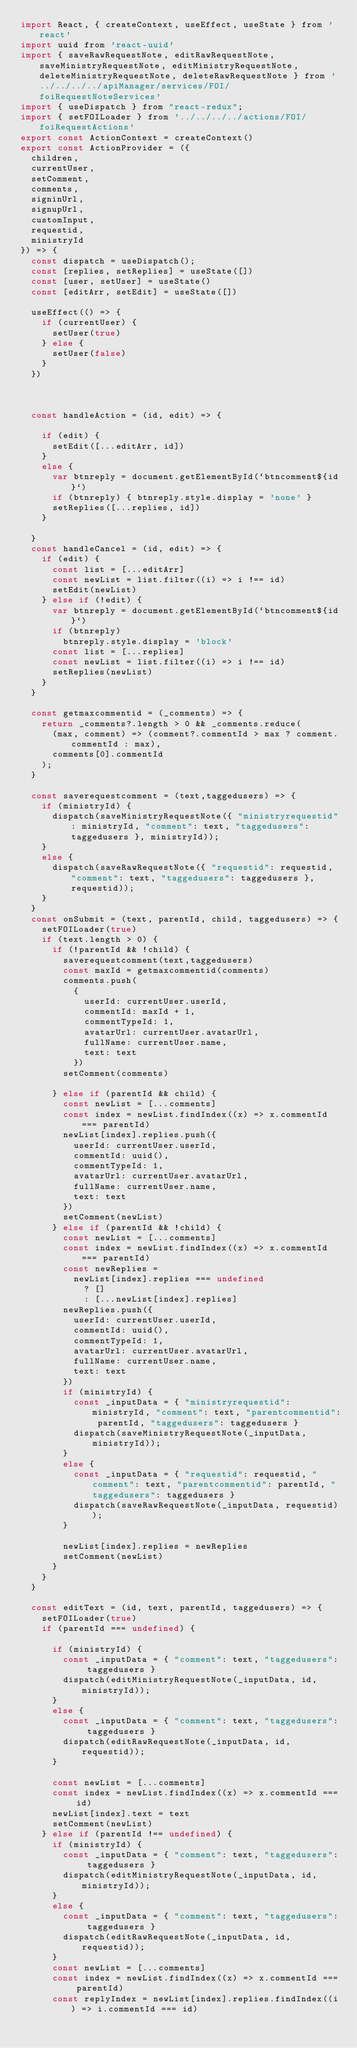<code> <loc_0><loc_0><loc_500><loc_500><_JavaScript_>import React, { createContext, useEffect, useState } from 'react'
import uuid from 'react-uuid'
import { saveRawRequestNote, editRawRequestNote, saveMinistryRequestNote, editMinistryRequestNote, deleteMinistryRequestNote, deleteRawRequestNote } from '../../../../apiManager/services/FOI/foiRequestNoteServices'
import { useDispatch } from "react-redux";
import { setFOILoader } from '../../../../actions/FOI/foiRequestActions'
export const ActionContext = createContext()
export const ActionProvider = ({
  children,
  currentUser,
  setComment,
  comments,
  signinUrl,
  signupUrl,
  customInput,
  requestid,
  ministryId
}) => {
  const dispatch = useDispatch();
  const [replies, setReplies] = useState([])
  const [user, setUser] = useState()
  const [editArr, setEdit] = useState([])

  useEffect(() => {
    if (currentUser) {
      setUser(true)
    } else {
      setUser(false)
    }
  })



  const handleAction = (id, edit) => {

    if (edit) {
      setEdit([...editArr, id])
    }
    else {
      var btnreply = document.getElementById(`btncomment${id}`)
      if (btnreply) { btnreply.style.display = 'none' }
      setReplies([...replies, id])
    }

  }
  const handleCancel = (id, edit) => {
    if (edit) {
      const list = [...editArr]
      const newList = list.filter((i) => i !== id)
      setEdit(newList)
    } else if (!edit) {
      var btnreply = document.getElementById(`btncomment${id}`)
      if (btnreply)
        btnreply.style.display = 'block'
      const list = [...replies]
      const newList = list.filter((i) => i !== id)
      setReplies(newList)
    }
  }

  const getmaxcommentid = (_comments) => {
    return _comments?.length > 0 && _comments.reduce(
      (max, comment) => (comment?.commentId > max ? comment.commentId : max),
      comments[0].commentId
    );
  }

  const saverequestcomment = (text,taggedusers) => {
    if (ministryId) {
      dispatch(saveMinistryRequestNote({ "ministryrequestid": ministryId, "comment": text, "taggedusers": taggedusers }, ministryId));
    }
    else {
      dispatch(saveRawRequestNote({ "requestid": requestid, "comment": text, "taggedusers": taggedusers }, requestid));
    }
  }
  const onSubmit = (text, parentId, child, taggedusers) => {
    setFOILoader(true)
    if (text.length > 0) {
      if (!parentId && !child) {
        saverequestcomment(text,taggedusers)
        const maxId = getmaxcommentid(comments)
        comments.push(
          {
            userId: currentUser.userId,
            commentId: maxId + 1,
            commentTypeId: 1,
            avatarUrl: currentUser.avatarUrl,
            fullName: currentUser.name,
            text: text
          })
        setComment(comments)

      } else if (parentId && child) {
        const newList = [...comments]
        const index = newList.findIndex((x) => x.commentId === parentId)
        newList[index].replies.push({
          userId: currentUser.userId,
          commentId: uuid(),
          commentTypeId: 1,
          avatarUrl: currentUser.avatarUrl,
          fullName: currentUser.name,
          text: text
        })
        setComment(newList)
      } else if (parentId && !child) {
        const newList = [...comments]
        const index = newList.findIndex((x) => x.commentId === parentId)
        const newReplies =
          newList[index].replies === undefined
            ? []
            : [...newList[index].replies]
        newReplies.push({
          userId: currentUser.userId,
          commentId: uuid(),
          commentTypeId: 1,
          avatarUrl: currentUser.avatarUrl,
          fullName: currentUser.name,
          text: text
        })
        if (ministryId) {
          const _inputData = { "ministryrequestid": ministryId, "comment": text, "parentcommentid": parentId, "taggedusers": taggedusers }
          dispatch(saveMinistryRequestNote(_inputData, ministryId));
        }
        else {
          const _inputData = { "requestid": requestid, "comment": text, "parentcommentid": parentId, "taggedusers": taggedusers }
          dispatch(saveRawRequestNote(_inputData, requestid));
        }

        newList[index].replies = newReplies
        setComment(newList)
      }
    }
  }

  const editText = (id, text, parentId, taggedusers) => {
    setFOILoader(true)
    if (parentId === undefined) {

      if (ministryId) {
        const _inputData = { "comment": text, "taggedusers": taggedusers }
        dispatch(editMinistryRequestNote(_inputData, id, ministryId));
      }
      else {
        const _inputData = { "comment": text, "taggedusers": taggedusers }
        dispatch(editRawRequestNote(_inputData, id, requestid));
      }

      const newList = [...comments]
      const index = newList.findIndex((x) => x.commentId === id)
      newList[index].text = text
      setComment(newList)
    } else if (parentId !== undefined) {
      if (ministryId) {
        const _inputData = { "comment": text, "taggedusers": taggedusers }
        dispatch(editMinistryRequestNote(_inputData, id, ministryId));
      }
      else {
        const _inputData = { "comment": text, "taggedusers": taggedusers }
        dispatch(editRawRequestNote(_inputData, id, requestid));
      }
      const newList = [...comments]
      const index = newList.findIndex((x) => x.commentId === parentId)
      const replyIndex = newList[index].replies.findIndex((i) => i.commentId === id)</code> 